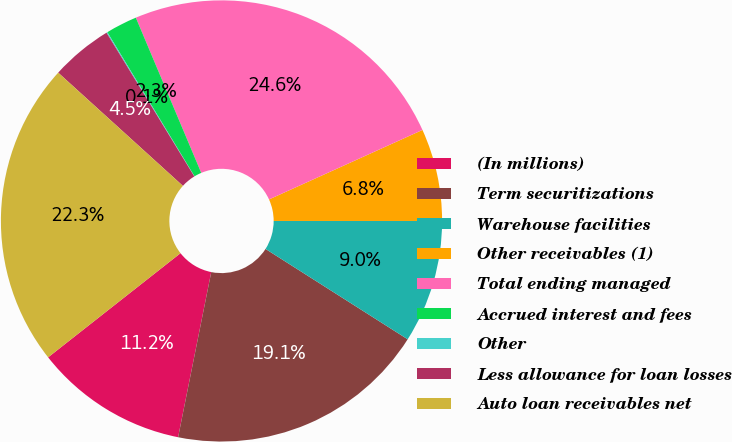Convert chart to OTSL. <chart><loc_0><loc_0><loc_500><loc_500><pie_chart><fcel>(In millions)<fcel>Term securitizations<fcel>Warehouse facilities<fcel>Other receivables (1)<fcel>Total ending managed<fcel>Accrued interest and fees<fcel>Other<fcel>Less allowance for loan losses<fcel>Auto loan receivables net<nl><fcel>11.24%<fcel>19.14%<fcel>9.01%<fcel>6.77%<fcel>24.58%<fcel>2.31%<fcel>0.07%<fcel>4.54%<fcel>22.34%<nl></chart> 